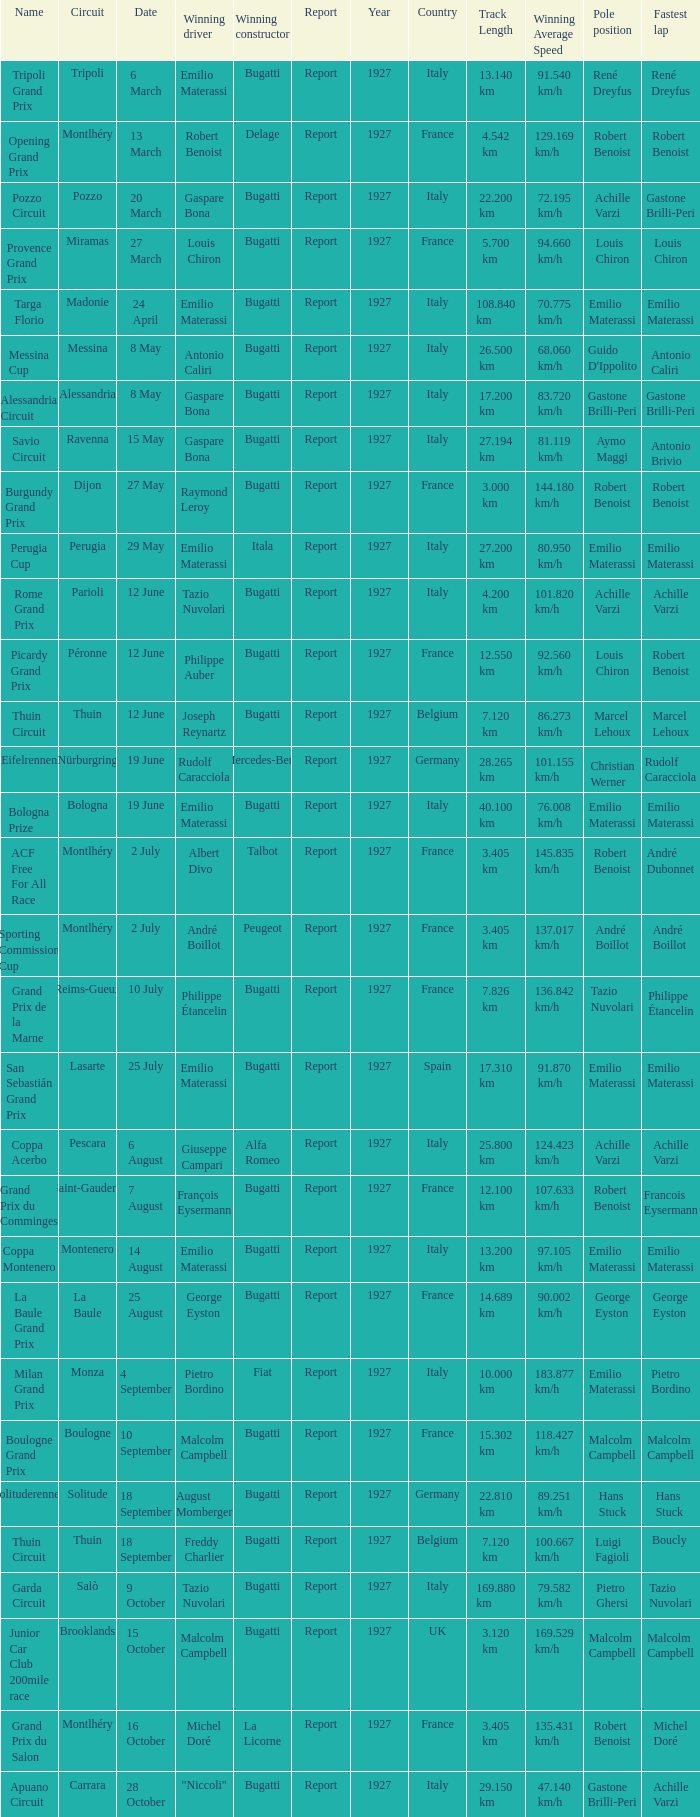Who was the winning constructor of the Grand Prix Du Salon ? La Licorne. 